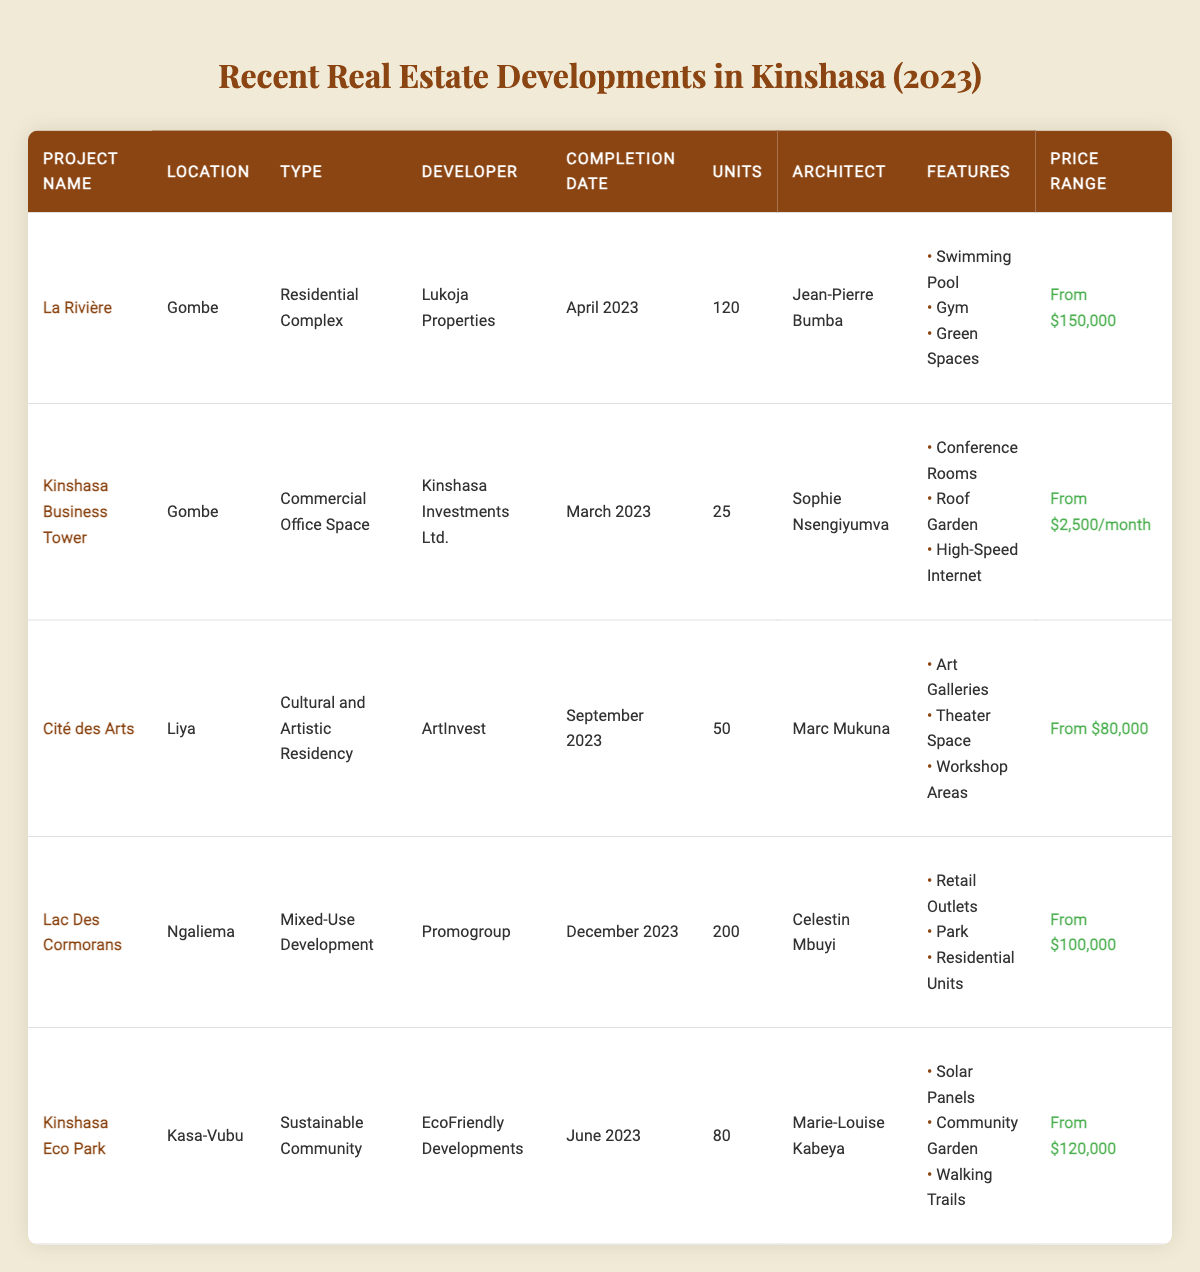What is the total number of residential units in Kinshasa's recent developments? From the table, the residential developments listed are "La Rivière" (120 units), "Lac Des Cormorans" (200 units), and "Kinshasa Eco Park" (80 units). Adding these together: 120 + 200 + 80 = 400 units.
Answer: 400 units Which project has the highest price range and what is that price? The project with the highest price range is "Kinshasa Business Tower," priced at "From $2,500/month." This can be confirmed by checking the price ranges listed for all projects.
Answer: From $2,500/month Is "Cité des Arts" completed before "Kinshasa Eco Park"? "Cité des Arts" was completed in September 2023, while "Kinshasa Eco Park" was completed in June 2023. Since June comes before September, the statement is false.
Answer: No What is the total number of units in commercial developments? There is only one commercial development listed, which is "Kinshasa Business Tower" with 25 units. Thus, the total is simply 25.
Answer: 25 units Which architect is responsible for the "Lac Des Cormorans" project? The architect listed for "Lac Des Cormorans" is Celestin Mbuyi. This information can be retrieved directly from the table under the architect column corresponding to that project.
Answer: Celestin Mbuyi What is the sum of units for all projects? The total units can be calculated by adding all the individual units: 120 (La Rivière) + 25 (Kinshasa Business Tower) + 50 (Cité des Arts) + 200 (Lac Des Cormorans) + 80 (Kinshasa Eco Park) = 475 units.
Answer: 475 units Are there more residential units than mixed-use units? "La Rivière" has 120 units and "Kinshasa Eco Park" has 80 units, totaling 200 residential units. "Lac Des Cormorans," the only mixed-use project, has 200 units. Thus, (200 < 200) is false._
Answer: No How many projects are completed in the first half of 2023? The projects completed in the first half of 2023 are "Kinshasa Business Tower" (March) and "La Rivière" (April). Therefore, there are 2 completed projects in that timeframe.
Answer: 2 projects Which location has the most projects listed? Both Gombe and Ngaliema have 2 projects listed each ("La Rivière," "Kinshasa Business Tower" for Gombe and "Lac Des Cormorans" for Ngaliema). Hence, they are tied in having the most projects.
Answer: Gombe and Ngaliema What are the unique features of "Kinshasa Eco Park"? The unique features of "Kinshasa Eco Park" are Solar Panels, Community Garden, and Walking Trails, as per the features listed for this project in the table.
Answer: Solar Panels, Community Garden, Walking Trails 